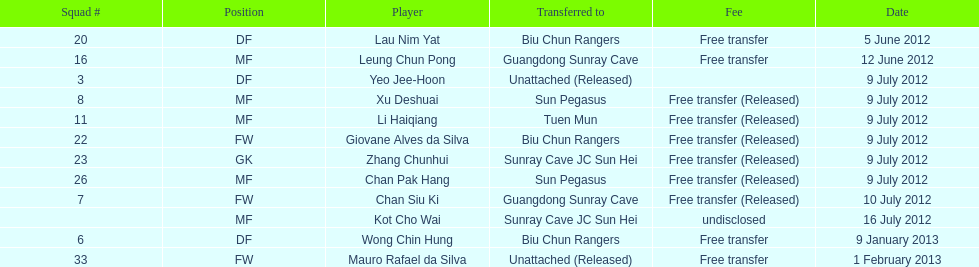How many players were consecutively released on the 9th of july? 6. 